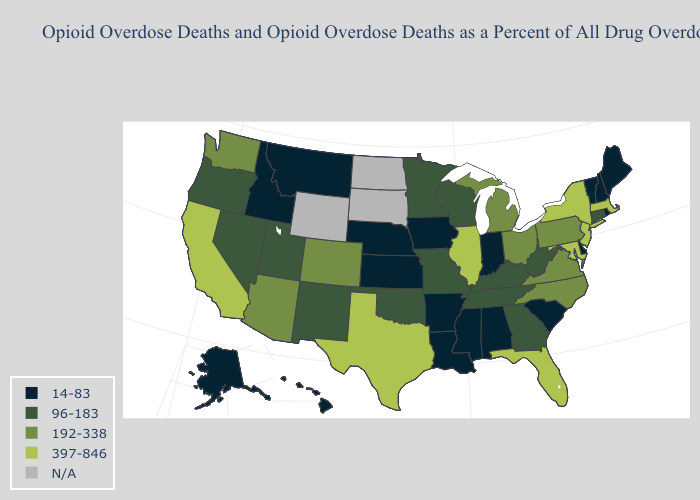Name the states that have a value in the range 14-83?
Answer briefly. Alabama, Alaska, Arkansas, Delaware, Hawaii, Idaho, Indiana, Iowa, Kansas, Louisiana, Maine, Mississippi, Montana, Nebraska, New Hampshire, Rhode Island, South Carolina, Vermont. Name the states that have a value in the range N/A?
Quick response, please. North Dakota, South Dakota, Wyoming. Does Nevada have the lowest value in the USA?
Answer briefly. No. Which states have the lowest value in the USA?
Write a very short answer. Alabama, Alaska, Arkansas, Delaware, Hawaii, Idaho, Indiana, Iowa, Kansas, Louisiana, Maine, Mississippi, Montana, Nebraska, New Hampshire, Rhode Island, South Carolina, Vermont. Name the states that have a value in the range 96-183?
Short answer required. Connecticut, Georgia, Kentucky, Minnesota, Missouri, Nevada, New Mexico, Oklahoma, Oregon, Tennessee, Utah, West Virginia, Wisconsin. What is the value of Arkansas?
Be succinct. 14-83. What is the lowest value in the MidWest?
Quick response, please. 14-83. What is the value of Ohio?
Keep it brief. 192-338. Name the states that have a value in the range 192-338?
Answer briefly. Arizona, Colorado, Michigan, North Carolina, Ohio, Pennsylvania, Virginia, Washington. What is the value of Illinois?
Keep it brief. 397-846. What is the value of New Hampshire?
Give a very brief answer. 14-83. What is the lowest value in the USA?
Concise answer only. 14-83. What is the highest value in the USA?
Write a very short answer. 397-846. Does Rhode Island have the lowest value in the Northeast?
Quick response, please. Yes. Does South Carolina have the lowest value in the USA?
Short answer required. Yes. 